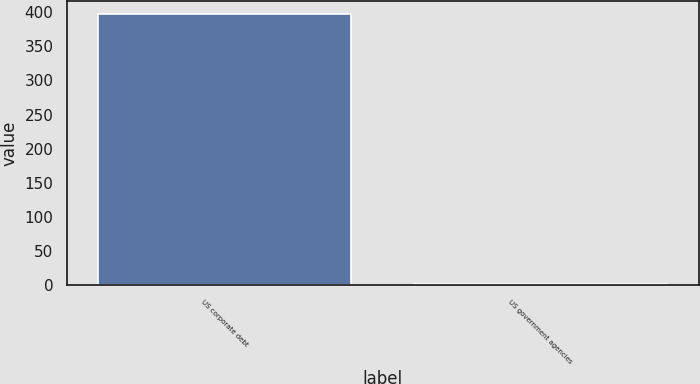<chart> <loc_0><loc_0><loc_500><loc_500><bar_chart><fcel>US corporate debt<fcel>US government agencies<nl><fcel>397<fcel>1<nl></chart> 